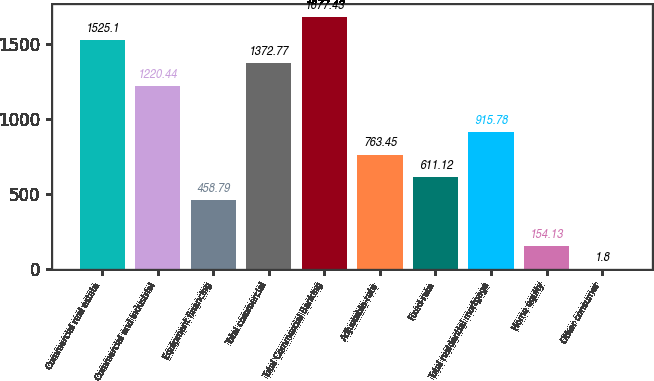Convert chart to OTSL. <chart><loc_0><loc_0><loc_500><loc_500><bar_chart><fcel>Commercial real estate<fcel>Commercial and industrial<fcel>Equipment financing<fcel>Total commercial<fcel>Total Commercial Banking<fcel>Adjustable-rate<fcel>Fixed-rate<fcel>Total residential mortgage<fcel>Home equity<fcel>Other consumer<nl><fcel>1525.1<fcel>1220.44<fcel>458.79<fcel>1372.77<fcel>1677.43<fcel>763.45<fcel>611.12<fcel>915.78<fcel>154.13<fcel>1.8<nl></chart> 